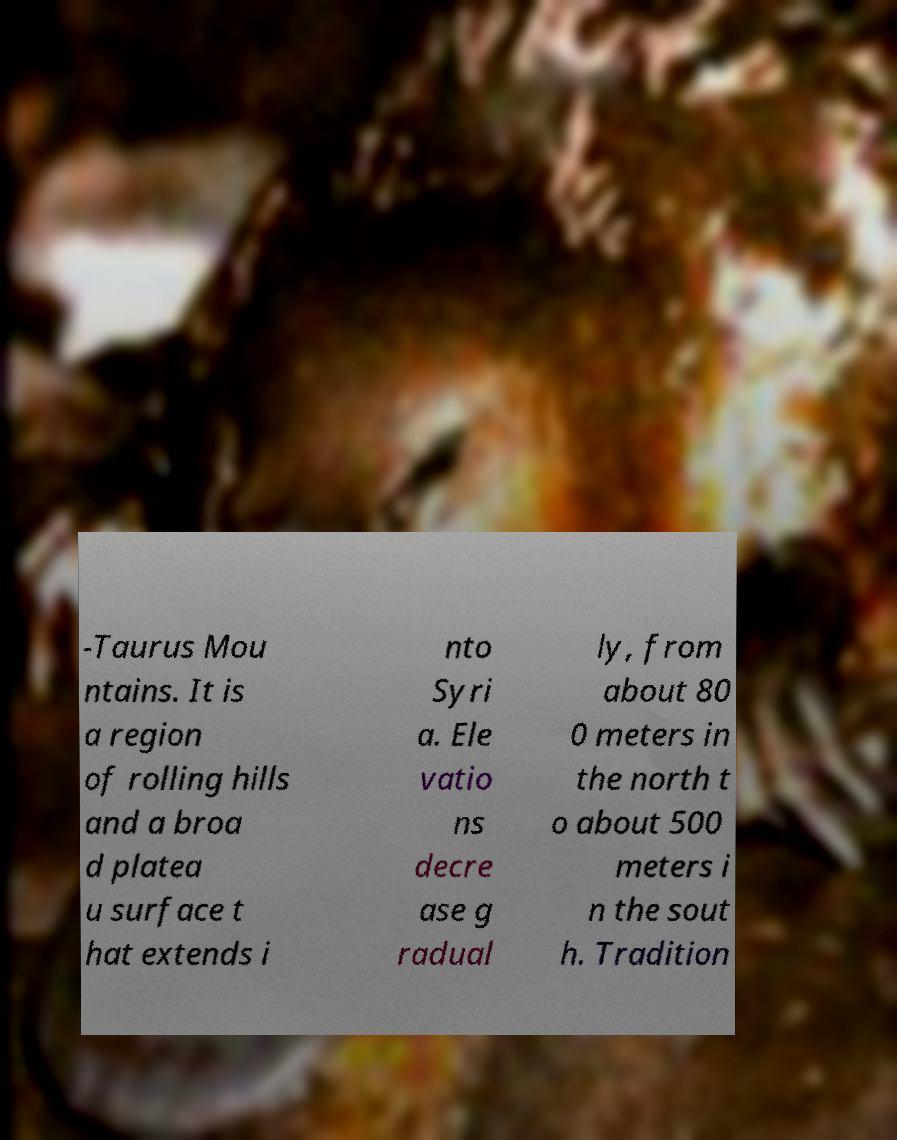I need the written content from this picture converted into text. Can you do that? -Taurus Mou ntains. It is a region of rolling hills and a broa d platea u surface t hat extends i nto Syri a. Ele vatio ns decre ase g radual ly, from about 80 0 meters in the north t o about 500 meters i n the sout h. Tradition 